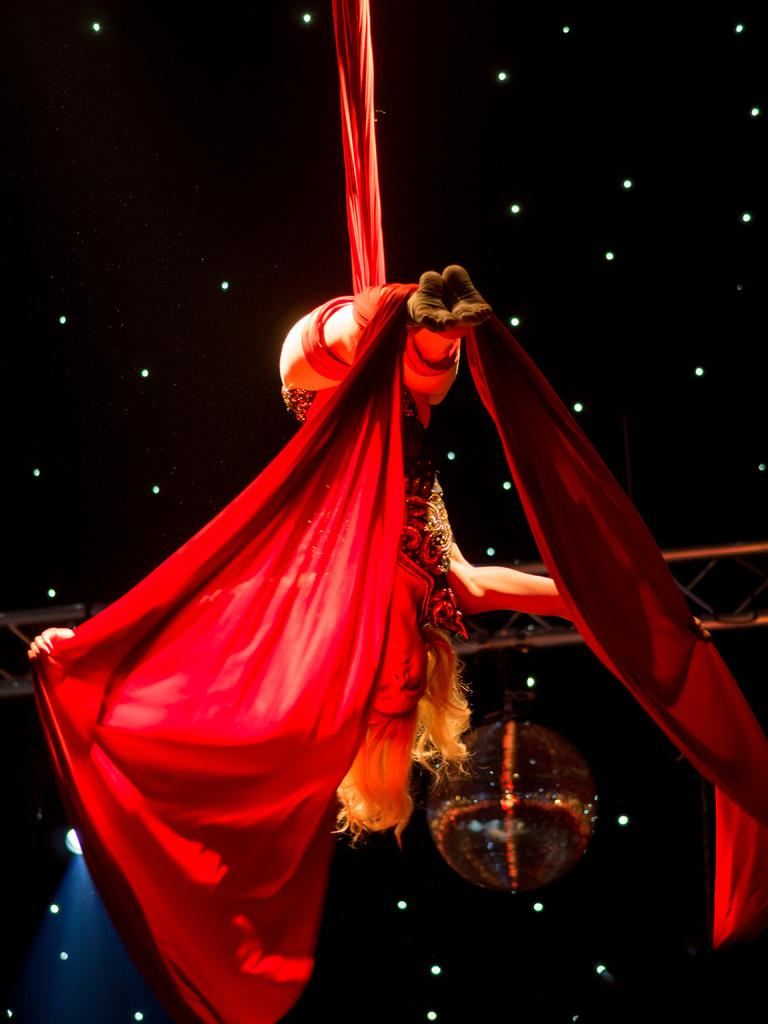Who or what is the main subject in the image? There is a person in the image. What is the person holding in the image? The person is holding a red color cloth. What can be seen in the background of the image? There is a pole and lights visible in the background of the image. What type of lunch is the person eating in the image? There is no indication in the image that the person is eating lunch, so it cannot be determined from the picture. 